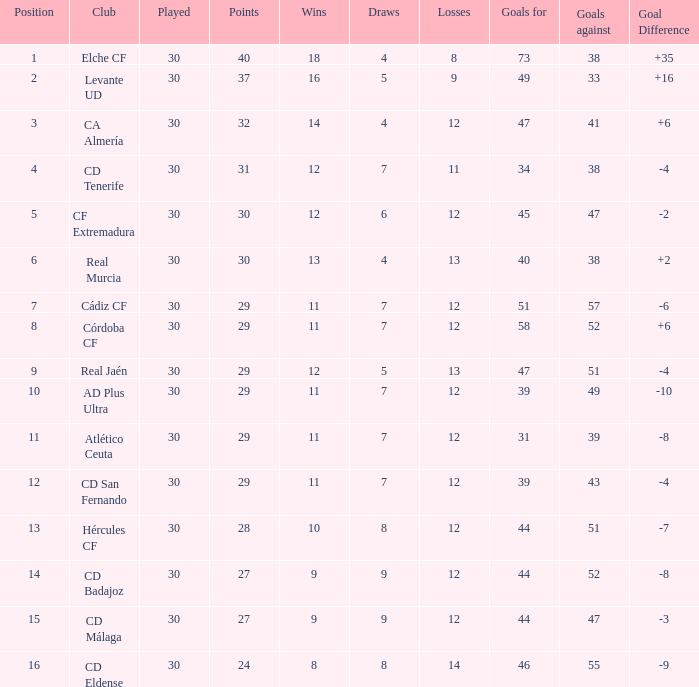What is the lowest amount of draws with less than 12 wins and less than 30 played? None. 